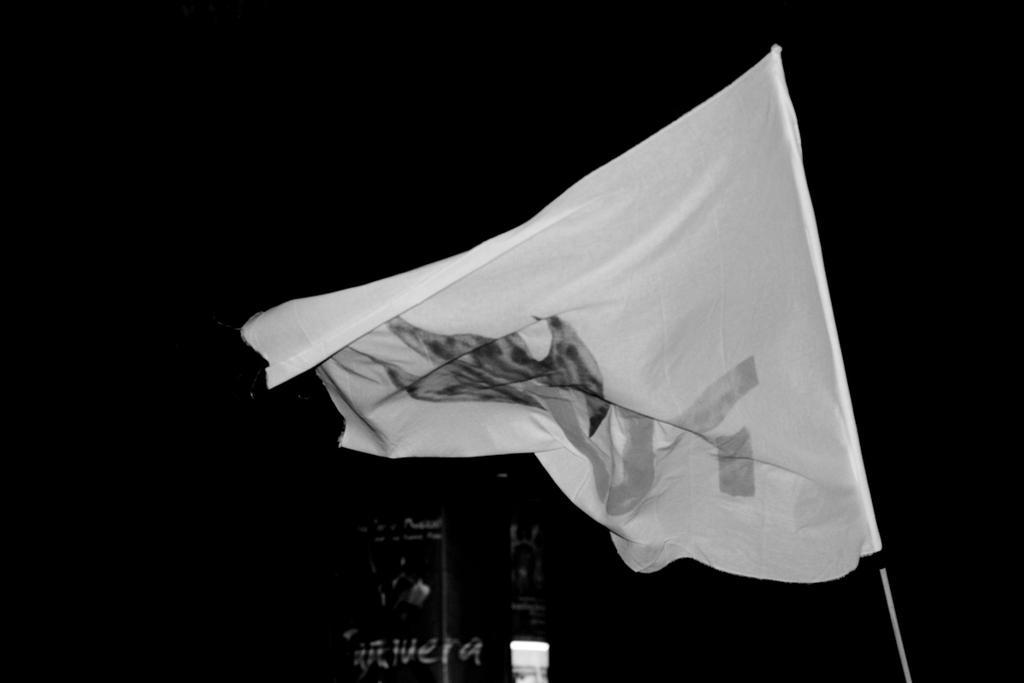Can you describe this image briefly? It is a black and white image. In this image we can see a flag and also the text and the background is in black color. 